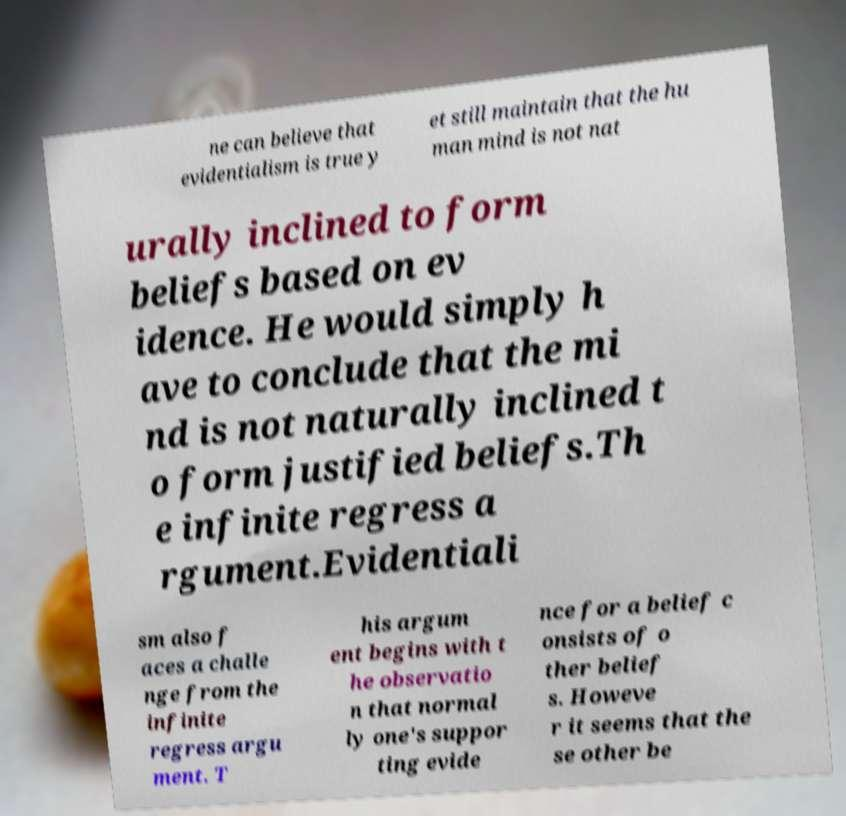Could you assist in decoding the text presented in this image and type it out clearly? ne can believe that evidentialism is true y et still maintain that the hu man mind is not nat urally inclined to form beliefs based on ev idence. He would simply h ave to conclude that the mi nd is not naturally inclined t o form justified beliefs.Th e infinite regress a rgument.Evidentiali sm also f aces a challe nge from the infinite regress argu ment. T his argum ent begins with t he observatio n that normal ly one's suppor ting evide nce for a belief c onsists of o ther belief s. Howeve r it seems that the se other be 